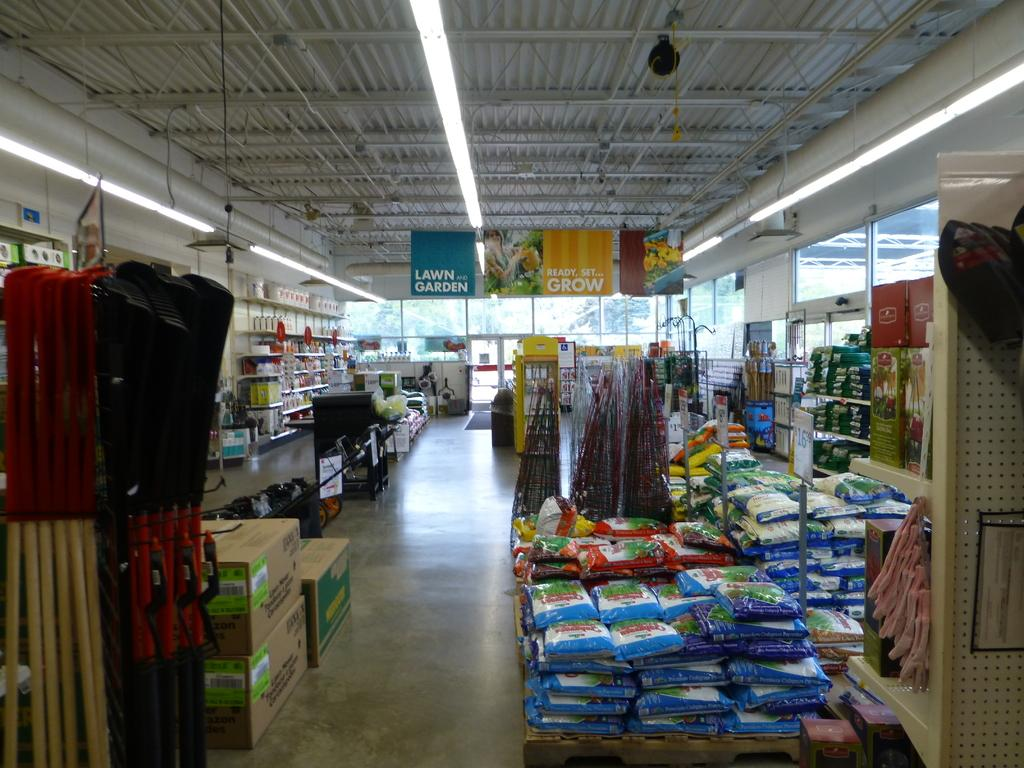Provide a one-sentence caption for the provided image. Empty store with a banner that says Ready, set, grow. 